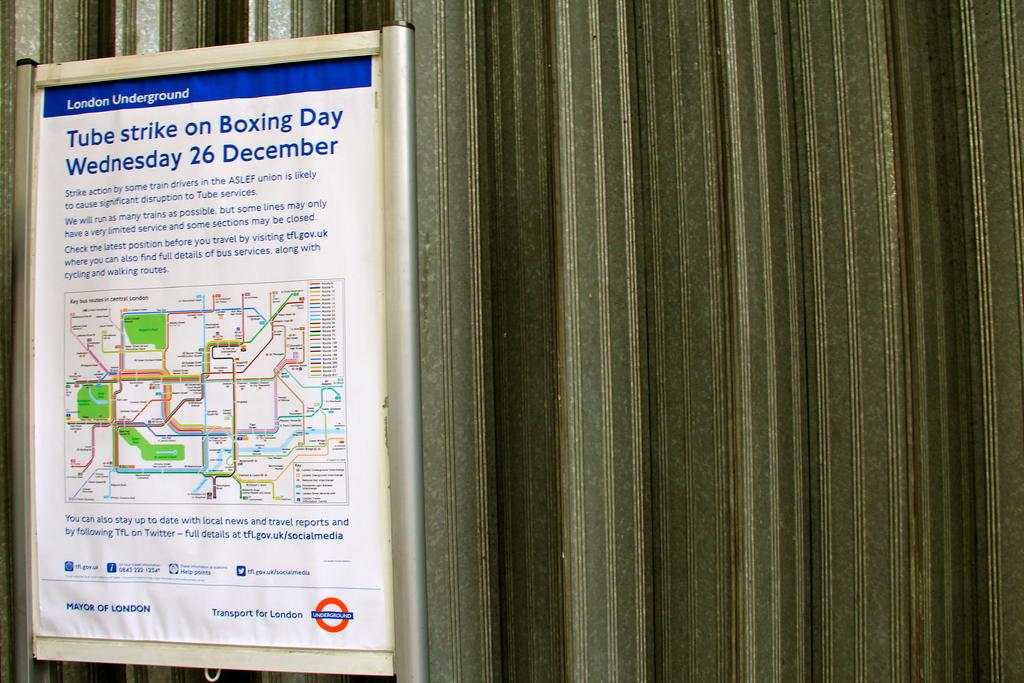Does the tube strike happen every 26th of december?
Your answer should be compact. Unanswerable. Whats the indication of the map?
Provide a short and direct response. Tube strike on boxing day. 